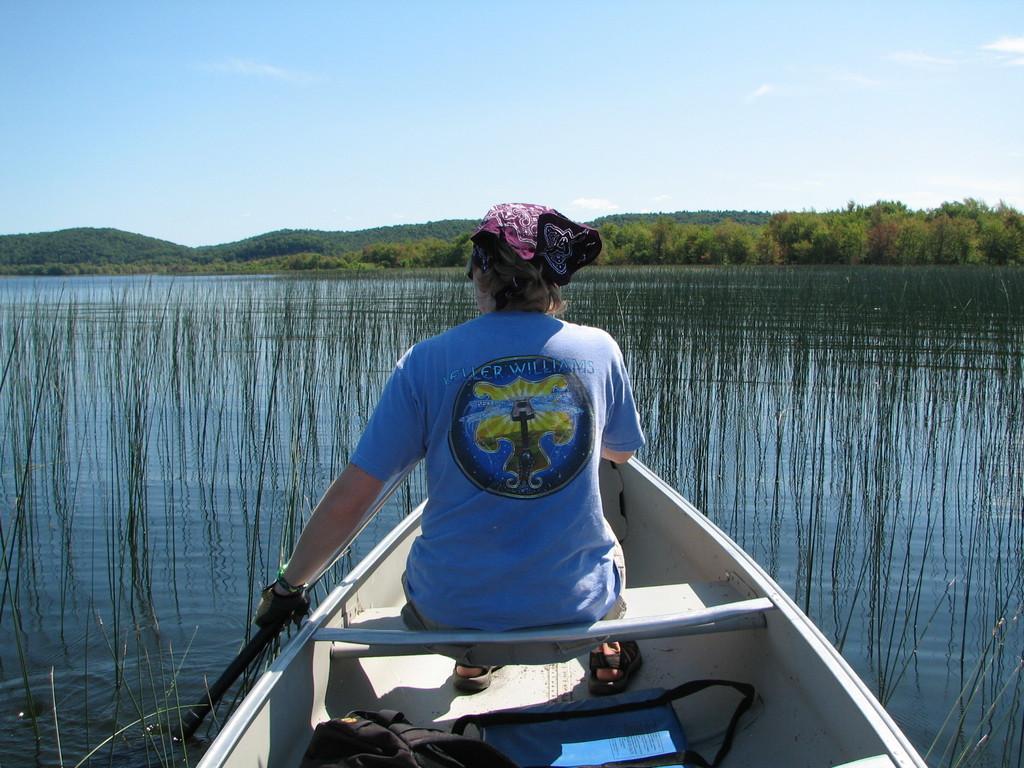How would you summarize this image in a sentence or two? In this image there is a woman sitting on a boat and sailing on a river, in the background there are trees, mountains and a sky. 